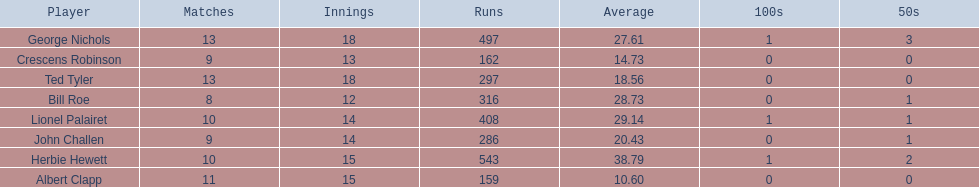Could you parse the entire table as a dict? {'header': ['Player', 'Matches', 'Innings', 'Runs', 'Average', '100s', '50s'], 'rows': [['George Nichols', '13', '18', '497', '27.61', '1', '3'], ['Crescens Robinson', '9', '13', '162', '14.73', '0', '0'], ['Ted Tyler', '13', '18', '297', '18.56', '0', '0'], ['Bill Roe', '8', '12', '316', '28.73', '0', '1'], ['Lionel Palairet', '10', '14', '408', '29.14', '1', '1'], ['John Challen', '9', '14', '286', '20.43', '0', '1'], ['Herbie Hewett', '10', '15', '543', '38.79', '1', '2'], ['Albert Clapp', '11', '15', '159', '10.60', '0', '0']]} Which players played in 10 or fewer matches? Herbie Hewett, Lionel Palairet, Bill Roe, John Challen, Crescens Robinson. Of these, which played in only 12 innings? Bill Roe. 